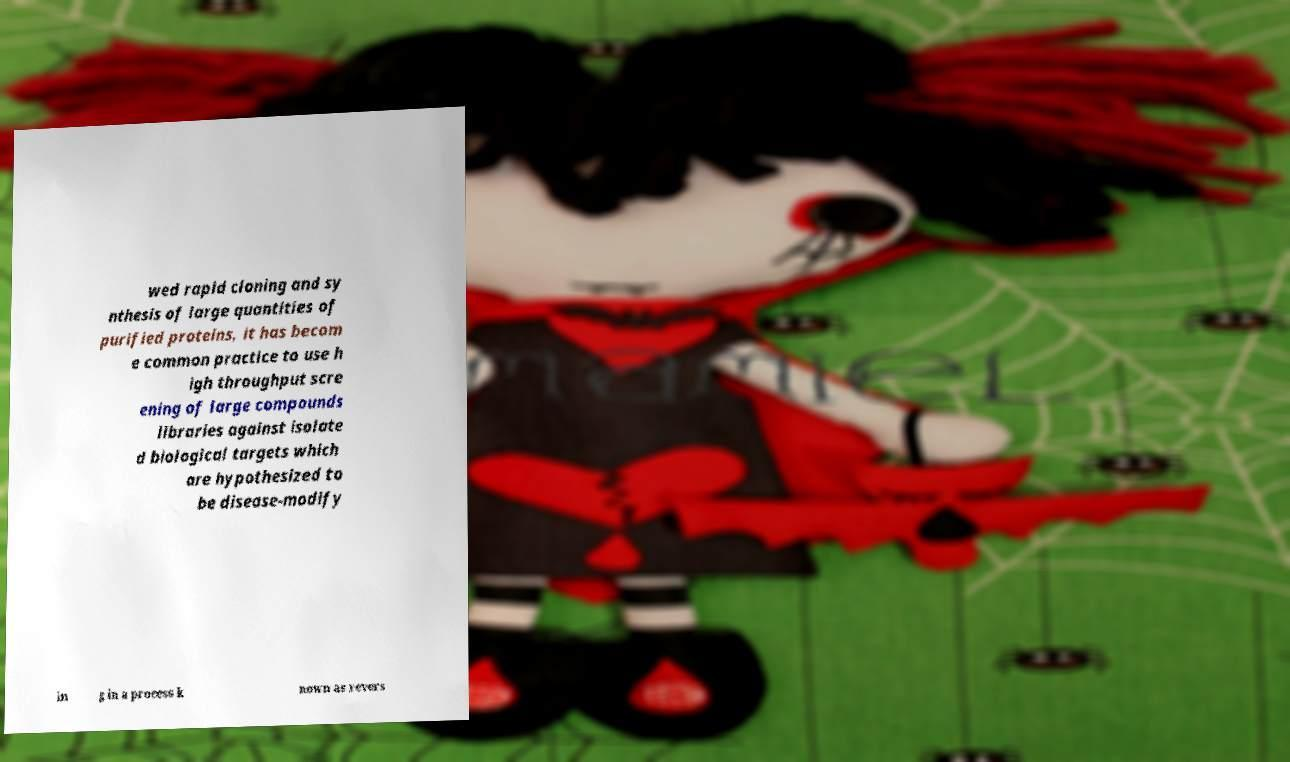Can you read and provide the text displayed in the image?This photo seems to have some interesting text. Can you extract and type it out for me? wed rapid cloning and sy nthesis of large quantities of purified proteins, it has becom e common practice to use h igh throughput scre ening of large compounds libraries against isolate d biological targets which are hypothesized to be disease-modify in g in a process k nown as revers 